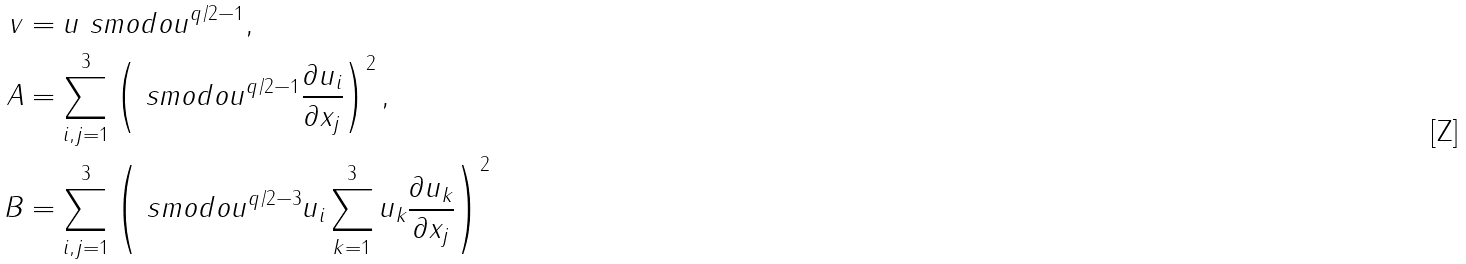Convert formula to latex. <formula><loc_0><loc_0><loc_500><loc_500>v & = u \ s m o d o u ^ { q / 2 - 1 } , \\ A & = \sum _ { i , j = 1 } ^ { 3 } \left ( \ s m o d o u ^ { q / 2 - 1 } \frac { \partial u _ { i } } { \partial x _ { j } } \right ) ^ { 2 } , \\ B & = \sum _ { i , j = 1 } ^ { 3 } \left ( \ s m o d o u ^ { q / 2 - 3 } u _ { i } \sum _ { k = 1 } ^ { 3 } u _ { k } \frac { \partial u _ { k } } { \partial x _ { j } } \right ) ^ { 2 }</formula> 